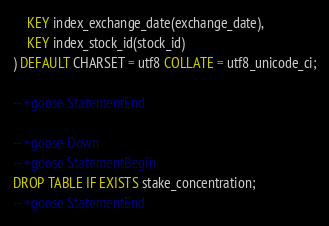<code> <loc_0><loc_0><loc_500><loc_500><_SQL_>    KEY index_exchange_date(exchange_date),
    KEY index_stock_id(stock_id)
) DEFAULT CHARSET = utf8 COLLATE = utf8_unicode_ci;

-- +goose StatementEnd

-- +goose Down
-- +goose StatementBegin
DROP TABLE IF EXISTS stake_concentration;
-- +goose StatementEnd
</code> 